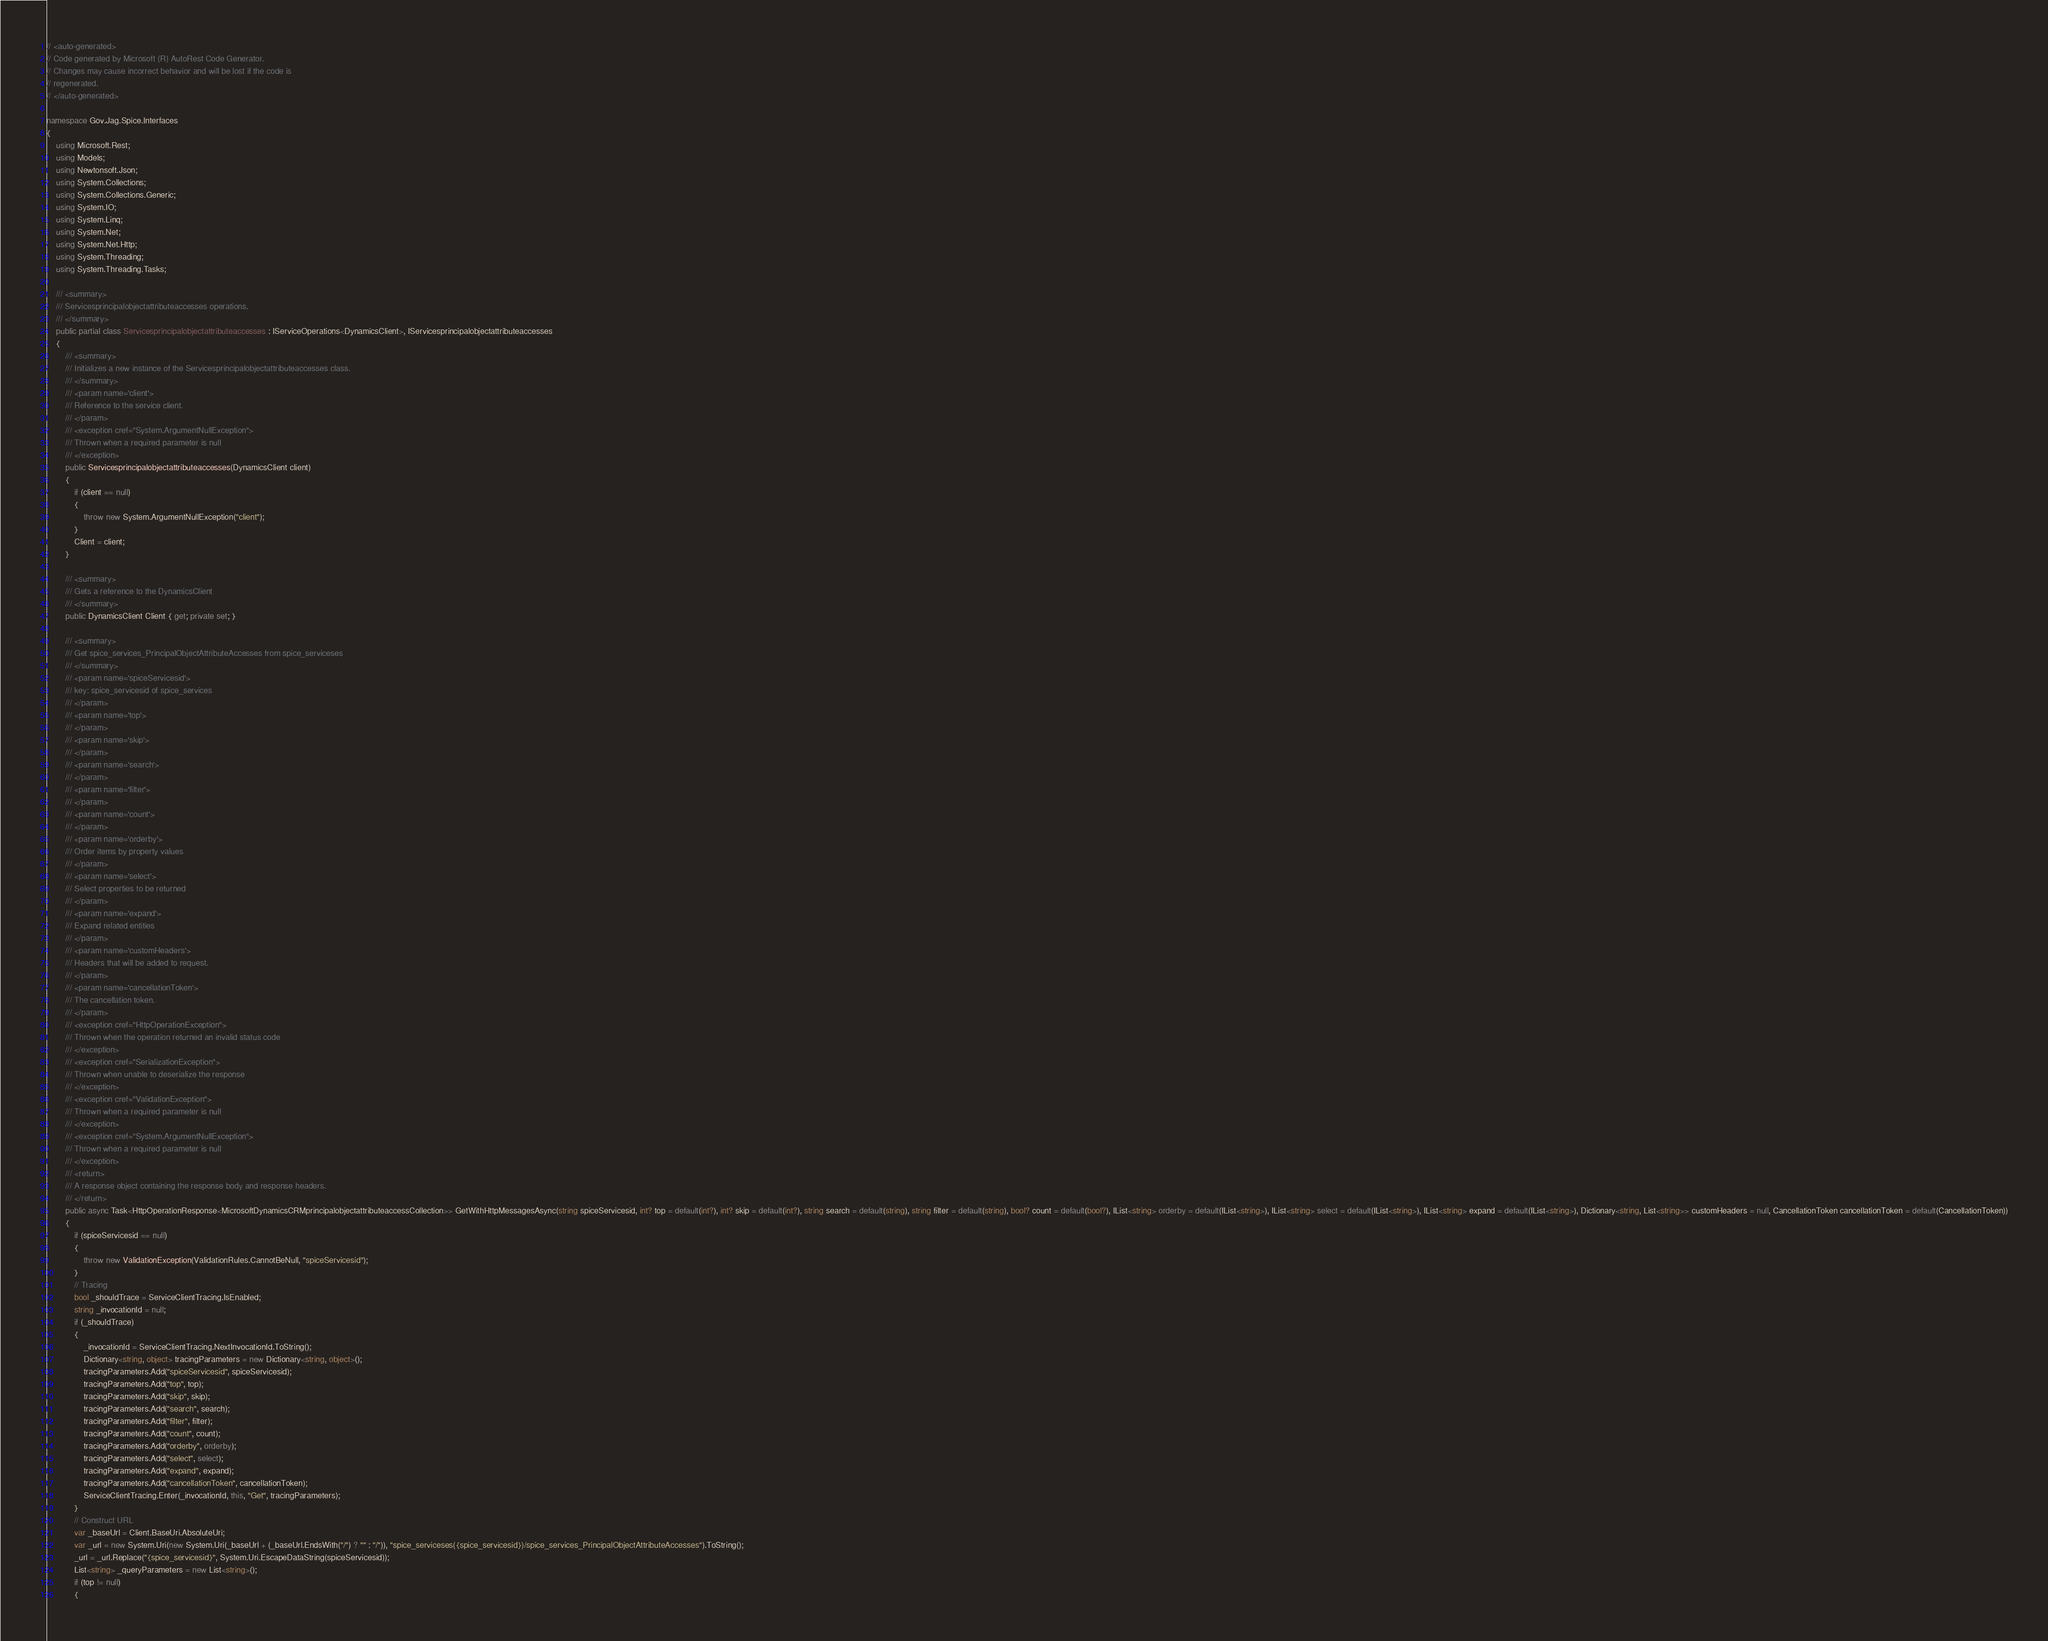<code> <loc_0><loc_0><loc_500><loc_500><_C#_>// <auto-generated>
// Code generated by Microsoft (R) AutoRest Code Generator.
// Changes may cause incorrect behavior and will be lost if the code is
// regenerated.
// </auto-generated>

namespace Gov.Jag.Spice.Interfaces
{
    using Microsoft.Rest;
    using Models;
    using Newtonsoft.Json;
    using System.Collections;
    using System.Collections.Generic;
    using System.IO;
    using System.Linq;
    using System.Net;
    using System.Net.Http;
    using System.Threading;
    using System.Threading.Tasks;

    /// <summary>
    /// Servicesprincipalobjectattributeaccesses operations.
    /// </summary>
    public partial class Servicesprincipalobjectattributeaccesses : IServiceOperations<DynamicsClient>, IServicesprincipalobjectattributeaccesses
    {
        /// <summary>
        /// Initializes a new instance of the Servicesprincipalobjectattributeaccesses class.
        /// </summary>
        /// <param name='client'>
        /// Reference to the service client.
        /// </param>
        /// <exception cref="System.ArgumentNullException">
        /// Thrown when a required parameter is null
        /// </exception>
        public Servicesprincipalobjectattributeaccesses(DynamicsClient client)
        {
            if (client == null)
            {
                throw new System.ArgumentNullException("client");
            }
            Client = client;
        }

        /// <summary>
        /// Gets a reference to the DynamicsClient
        /// </summary>
        public DynamicsClient Client { get; private set; }

        /// <summary>
        /// Get spice_services_PrincipalObjectAttributeAccesses from spice_serviceses
        /// </summary>
        /// <param name='spiceServicesid'>
        /// key: spice_servicesid of spice_services
        /// </param>
        /// <param name='top'>
        /// </param>
        /// <param name='skip'>
        /// </param>
        /// <param name='search'>
        /// </param>
        /// <param name='filter'>
        /// </param>
        /// <param name='count'>
        /// </param>
        /// <param name='orderby'>
        /// Order items by property values
        /// </param>
        /// <param name='select'>
        /// Select properties to be returned
        /// </param>
        /// <param name='expand'>
        /// Expand related entities
        /// </param>
        /// <param name='customHeaders'>
        /// Headers that will be added to request.
        /// </param>
        /// <param name='cancellationToken'>
        /// The cancellation token.
        /// </param>
        /// <exception cref="HttpOperationException">
        /// Thrown when the operation returned an invalid status code
        /// </exception>
        /// <exception cref="SerializationException">
        /// Thrown when unable to deserialize the response
        /// </exception>
        /// <exception cref="ValidationException">
        /// Thrown when a required parameter is null
        /// </exception>
        /// <exception cref="System.ArgumentNullException">
        /// Thrown when a required parameter is null
        /// </exception>
        /// <return>
        /// A response object containing the response body and response headers.
        /// </return>
        public async Task<HttpOperationResponse<MicrosoftDynamicsCRMprincipalobjectattributeaccessCollection>> GetWithHttpMessagesAsync(string spiceServicesid, int? top = default(int?), int? skip = default(int?), string search = default(string), string filter = default(string), bool? count = default(bool?), IList<string> orderby = default(IList<string>), IList<string> select = default(IList<string>), IList<string> expand = default(IList<string>), Dictionary<string, List<string>> customHeaders = null, CancellationToken cancellationToken = default(CancellationToken))
        {
            if (spiceServicesid == null)
            {
                throw new ValidationException(ValidationRules.CannotBeNull, "spiceServicesid");
            }
            // Tracing
            bool _shouldTrace = ServiceClientTracing.IsEnabled;
            string _invocationId = null;
            if (_shouldTrace)
            {
                _invocationId = ServiceClientTracing.NextInvocationId.ToString();
                Dictionary<string, object> tracingParameters = new Dictionary<string, object>();
                tracingParameters.Add("spiceServicesid", spiceServicesid);
                tracingParameters.Add("top", top);
                tracingParameters.Add("skip", skip);
                tracingParameters.Add("search", search);
                tracingParameters.Add("filter", filter);
                tracingParameters.Add("count", count);
                tracingParameters.Add("orderby", orderby);
                tracingParameters.Add("select", select);
                tracingParameters.Add("expand", expand);
                tracingParameters.Add("cancellationToken", cancellationToken);
                ServiceClientTracing.Enter(_invocationId, this, "Get", tracingParameters);
            }
            // Construct URL
            var _baseUrl = Client.BaseUri.AbsoluteUri;
            var _url = new System.Uri(new System.Uri(_baseUrl + (_baseUrl.EndsWith("/") ? "" : "/")), "spice_serviceses({spice_servicesid})/spice_services_PrincipalObjectAttributeAccesses").ToString();
            _url = _url.Replace("{spice_servicesid}", System.Uri.EscapeDataString(spiceServicesid));
            List<string> _queryParameters = new List<string>();
            if (top != null)
            {</code> 